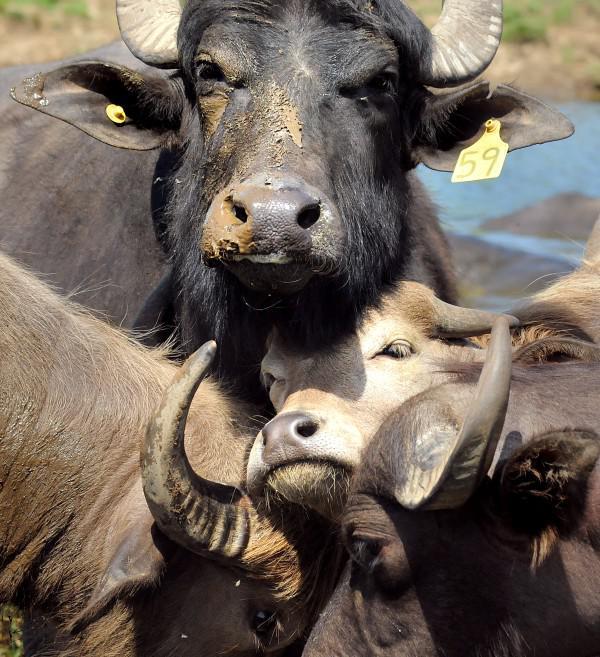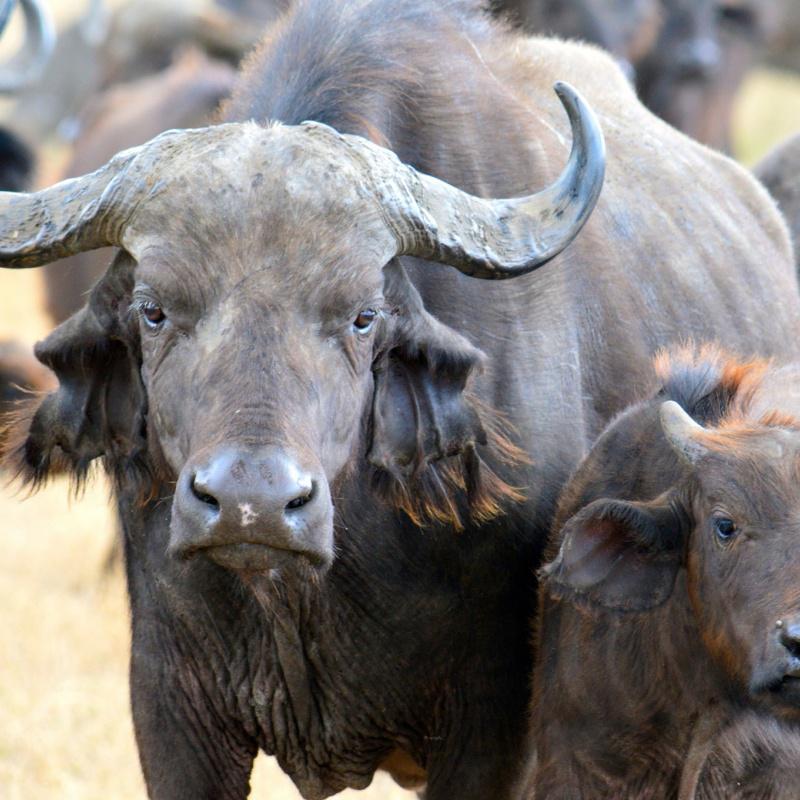The first image is the image on the left, the second image is the image on the right. Considering the images on both sides, is "In at least one image there is a single round horned ox standing next to it brown cafe" valid? Answer yes or no. Yes. The first image is the image on the left, the second image is the image on the right. Analyze the images presented: Is the assertion "The left image includes a forward-facing buffalo with other buffalo in the background at the left, and the right image shows a buffalo with a different type of animal on its back." valid? Answer yes or no. No. 